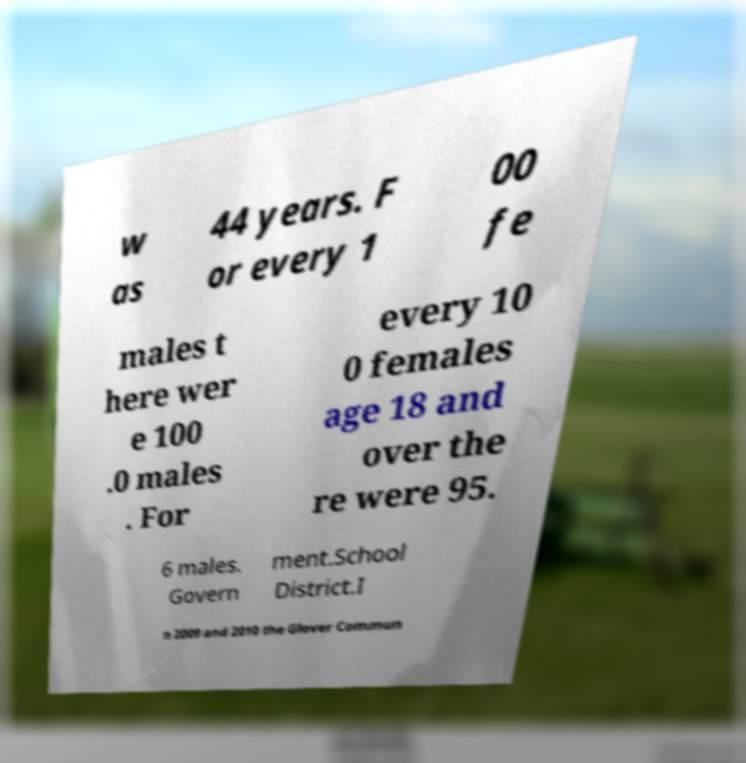For documentation purposes, I need the text within this image transcribed. Could you provide that? w as 44 years. F or every 1 00 fe males t here wer e 100 .0 males . For every 10 0 females age 18 and over the re were 95. 6 males. Govern ment.School District.I n 2009 and 2010 the Glover Commun 